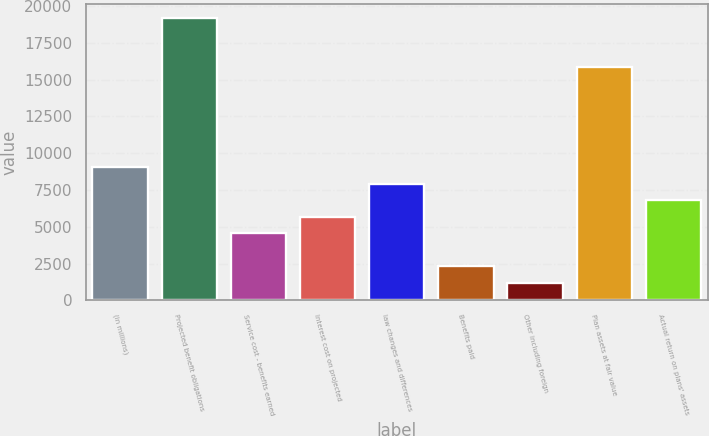Convert chart to OTSL. <chart><loc_0><loc_0><loc_500><loc_500><bar_chart><fcel>(in millions)<fcel>Projected benefit obligations<fcel>Service cost - benefits earned<fcel>Interest cost on projected<fcel>law changes and differences<fcel>Benefits paid<fcel>Other including foreign<fcel>Plan assets at fair value<fcel>Actual return on plans' assets<nl><fcel>9069.8<fcel>19204.7<fcel>4565.4<fcel>5691.5<fcel>7943.7<fcel>2313.2<fcel>1187.1<fcel>15826.4<fcel>6817.6<nl></chart> 